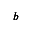Convert formula to latex. <formula><loc_0><loc_0><loc_500><loc_500>\pm b { b }</formula> 